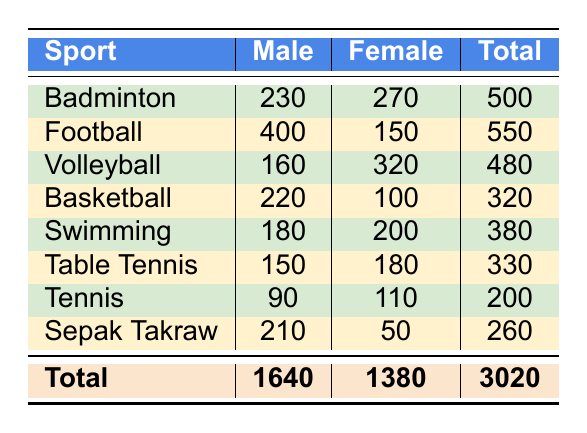What sport has the highest participation among males? From the table, I can see that Football has 400 male participants, which is higher than the number of male participants in any other sport listed.
Answer: Football What sport has the highest female participation? By examining the table, Volleyball has the highest female participation with 320 participants, which is greater than the female participants in any other sport listed.
Answer: Volleyball What is the total number of males participating in all sports? To find the total number of male participants, I will add the numbers for males across all sports: 230 + 400 + 160 + 220 + 180 + 150 + 90 + 210 = 1640.
Answer: 1640 What is the total number of participants in Badminton? The total number of participants in Badminton is calculated by adding the male and female participants: 230 (Male) + 270 (Female) = 500.
Answer: 500 Is the number of male participants in Tennis higher than in Table Tennis? According to the table, Tennis has 90 male participants while Table Tennis has 150 male participants, thus male participation in Tennis is not higher.
Answer: No What sport has the lowest total participation? To find the sport with the lowest total participation, I will compare the total numbers: Badminton (500), Football (550), Volleyball (480), Basketball (320), Swimming (380), Table Tennis (330), Tennis (200), Sepak Takraw (260). The lowest total is in Tennis with 200 participants.
Answer: Tennis Which sport has more female participants than male participants? Looking at the table, Volleyball (320 female vs. 160 male) and Badminton (270 female vs. 230 male) are the only sports where female participation exceeds male participation.
Answer: Volleyball and Badminton What is the difference in participation between male and female in Swimming? For Swimming, male participants are 180 and female participants are 200. The difference is calculated as: 200 (Female) - 180 (Male) = 20.
Answer: 20 What is the average number of participants for all sports combined? To find the average number of participants, I will first sum up all total participants: 500 + 550 + 480 + 320 + 380 + 330 + 200 + 260 = 3020. Since there are 8 sports, the average is 3020 / 8 = 377.5.
Answer: 377.5 